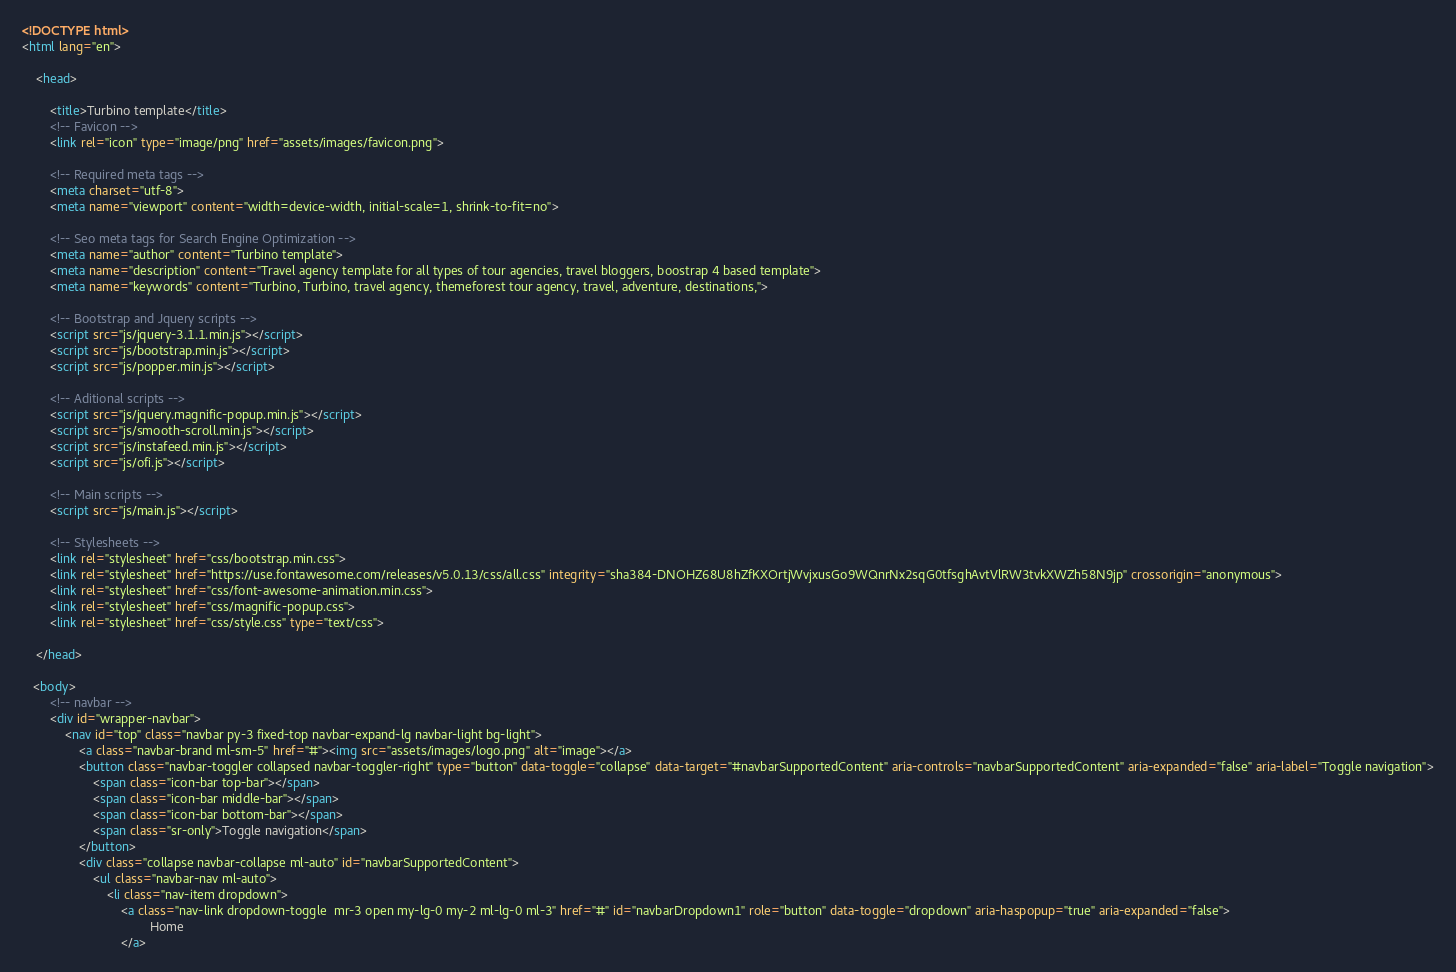Convert code to text. <code><loc_0><loc_0><loc_500><loc_500><_HTML_><!DOCTYPE html>
<html lang="en">

    <head>

        <title>Turbino template</title>
        <!-- Favicon -->
        <link rel="icon" type="image/png" href="assets/images/favicon.png">

        <!-- Required meta tags -->
        <meta charset="utf-8">
        <meta name="viewport" content="width=device-width, initial-scale=1, shrink-to-fit=no">

        <!-- Seo meta tags for Search Engine Optimization -->
        <meta name="author" content="Turbino template">
        <meta name="description" content="Travel agency template for all types of tour agencies, travel bloggers, boostrap 4 based template">
        <meta name="keywords" content="Turbino, Turbino, travel agency, themeforest tour agency, travel, adventure, destinations,">

        <!-- Bootstrap and Jquery scripts -->
        <script src="js/jquery-3.1.1.min.js"></script>
        <script src="js/bootstrap.min.js"></script>
        <script src="js/popper.min.js"></script>

        <!-- Aditional scripts -->
        <script src="js/jquery.magnific-popup.min.js"></script>
        <script src="js/smooth-scroll.min.js"></script>
        <script src="js/instafeed.min.js"></script>
        <script src="js/ofi.js"></script>

        <!-- Main scripts -->
        <script src="js/main.js"></script>

        <!-- Stylesheets -->
        <link rel="stylesheet" href="css/bootstrap.min.css">
        <link rel="stylesheet" href="https://use.fontawesome.com/releases/v5.0.13/css/all.css" integrity="sha384-DNOHZ68U8hZfKXOrtjWvjxusGo9WQnrNx2sqG0tfsghAvtVlRW3tvkXWZh58N9jp" crossorigin="anonymous">
        <link rel="stylesheet" href="css/font-awesome-animation.min.css">
        <link rel="stylesheet" href="css/magnific-popup.css">
        <link rel="stylesheet" href="css/style.css" type="text/css">

    </head>

   <body>
        <!-- navbar -->
        <div id="wrapper-navbar">
            <nav id="top" class="navbar py-3 fixed-top navbar-expand-lg navbar-light bg-light">
                <a class="navbar-brand ml-sm-5" href="#"><img src="assets/images/logo.png" alt="image"></a>
                <button class="navbar-toggler collapsed navbar-toggler-right" type="button" data-toggle="collapse" data-target="#navbarSupportedContent" aria-controls="navbarSupportedContent" aria-expanded="false" aria-label="Toggle navigation">
                    <span class="icon-bar top-bar"></span>
                    <span class="icon-bar middle-bar"></span>
                    <span class="icon-bar bottom-bar"></span>
                    <span class="sr-only">Toggle navigation</span>
                </button> 
                <div class="collapse navbar-collapse ml-auto" id="navbarSupportedContent">
                    <ul class="navbar-nav ml-auto">
                        <li class="nav-item dropdown">
                            <a class="nav-link dropdown-toggle  mr-3 open my-lg-0 my-2 ml-lg-0 ml-3" href="#" id="navbarDropdown1" role="button" data-toggle="dropdown" aria-haspopup="true" aria-expanded="false">
                                    Home
                            </a></code> 